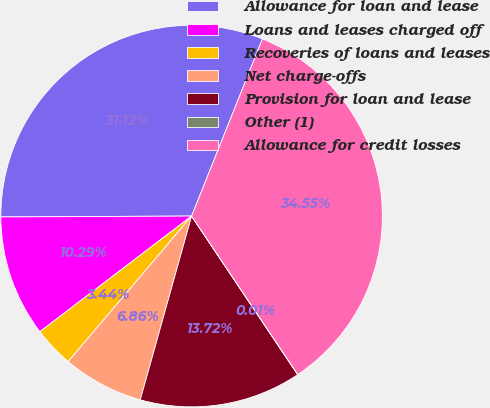Convert chart. <chart><loc_0><loc_0><loc_500><loc_500><pie_chart><fcel>Allowance for loan and lease<fcel>Loans and leases charged off<fcel>Recoveries of loans and leases<fcel>Net charge-offs<fcel>Provision for loan and lease<fcel>Other (1)<fcel>Allowance for credit losses<nl><fcel>31.12%<fcel>10.29%<fcel>3.44%<fcel>6.86%<fcel>13.72%<fcel>0.01%<fcel>34.55%<nl></chart> 